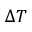<formula> <loc_0><loc_0><loc_500><loc_500>\Delta T</formula> 